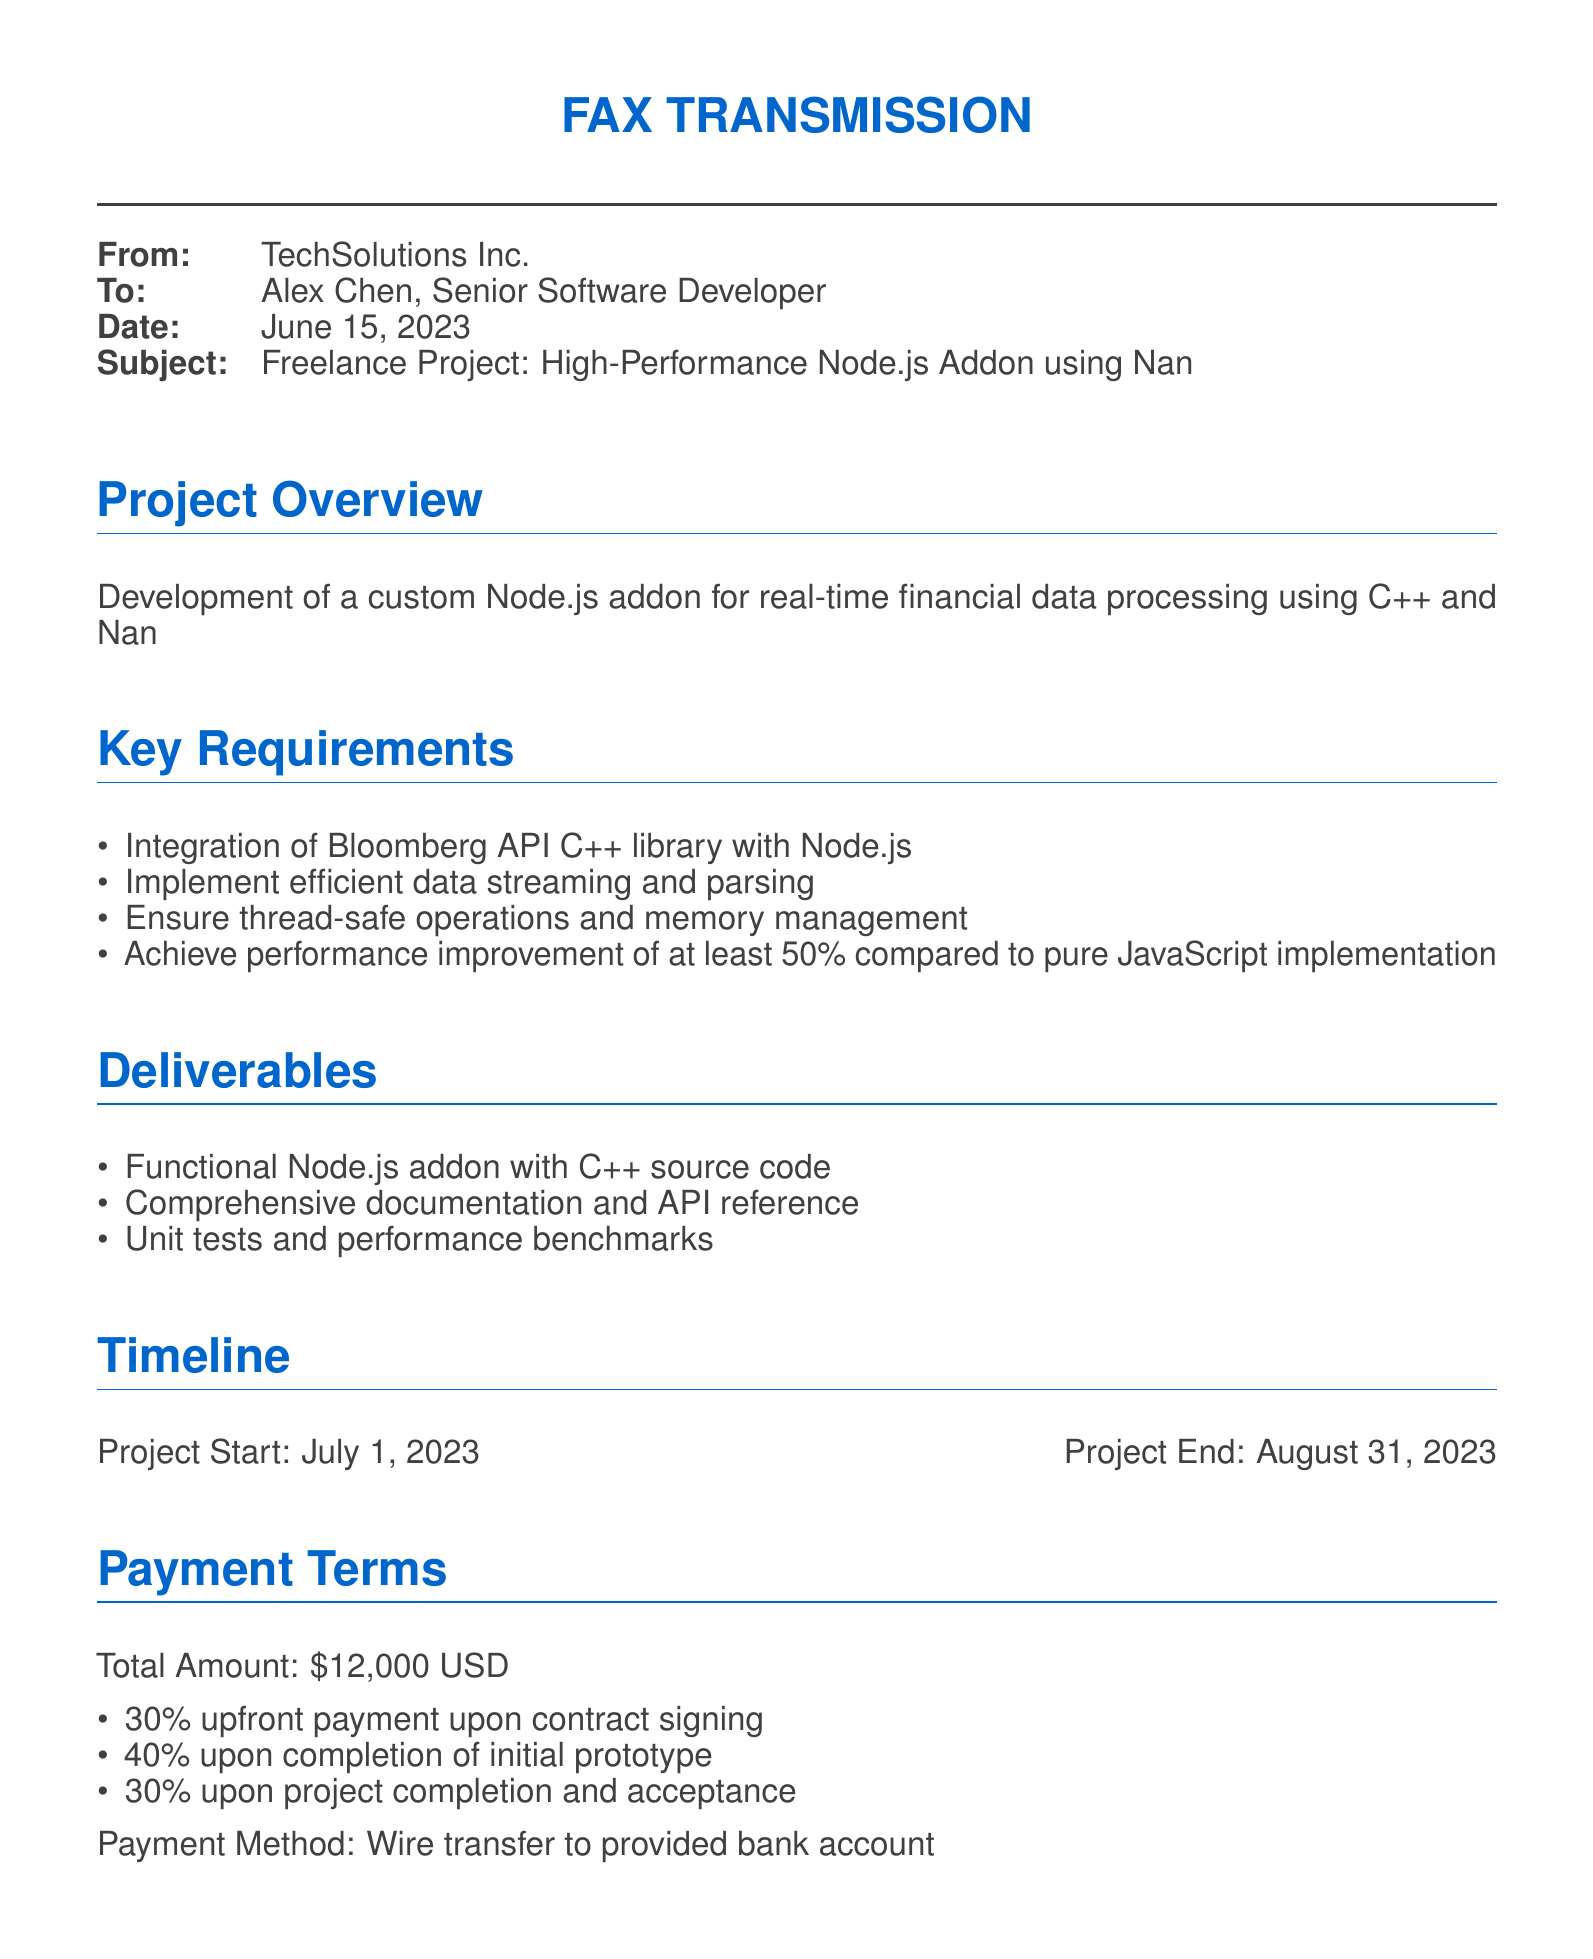What is the total project amount? The total project amount is specified under the payment terms in the document.
Answer: $12,000 USD Who is the recipient of the fax? The recipient's name and title can be found at the beginning of the document.
Answer: Alex Chen, Senior Software Developer What is the project start date? The project start date is mentioned in the timeline section of the document.
Answer: July 1, 2023 What percentage of the total amount is due upon contract signing? The upfront payment percentage is outlined in the payment terms section.
Answer: 30% What is one deliverable of the project? The deliverables section lists the items to be provided upon project completion.
Answer: Functional Node.js addon with C++ source code What is the confidentiality clause? The confidentiality clause is stated in the legal considerations section of the document.
Answer: All project details and source code are to be kept strictly confidential What is the payment method? The payment method is described in the payment terms section of the document.
Answer: Wire transfer to provided bank account What is the performance improvement target? The performance improvement target is detailed in the key requirements section of the document.
Answer: 50% compared to pure JavaScript implementation What is the project end date? The project end date can be found in the timeline section of the document.
Answer: August 31, 2023 